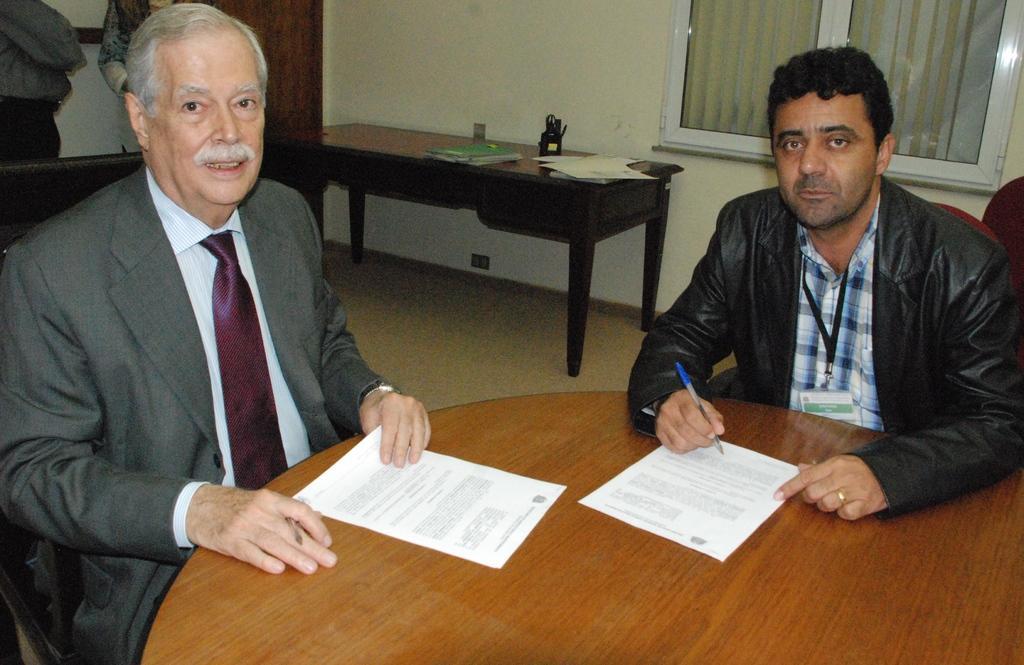Could you give a brief overview of what you see in this image? On the background we can see a wall, door, window. This is a table and on the table we can see book, pages and a black colour mug and scissors in it. This is a floor. Here we can see persons standing near to the door. We can see two men sittong on chairs infront of a table oand on the table we can see papers. Both persons are holding pens and papers in their hands. 